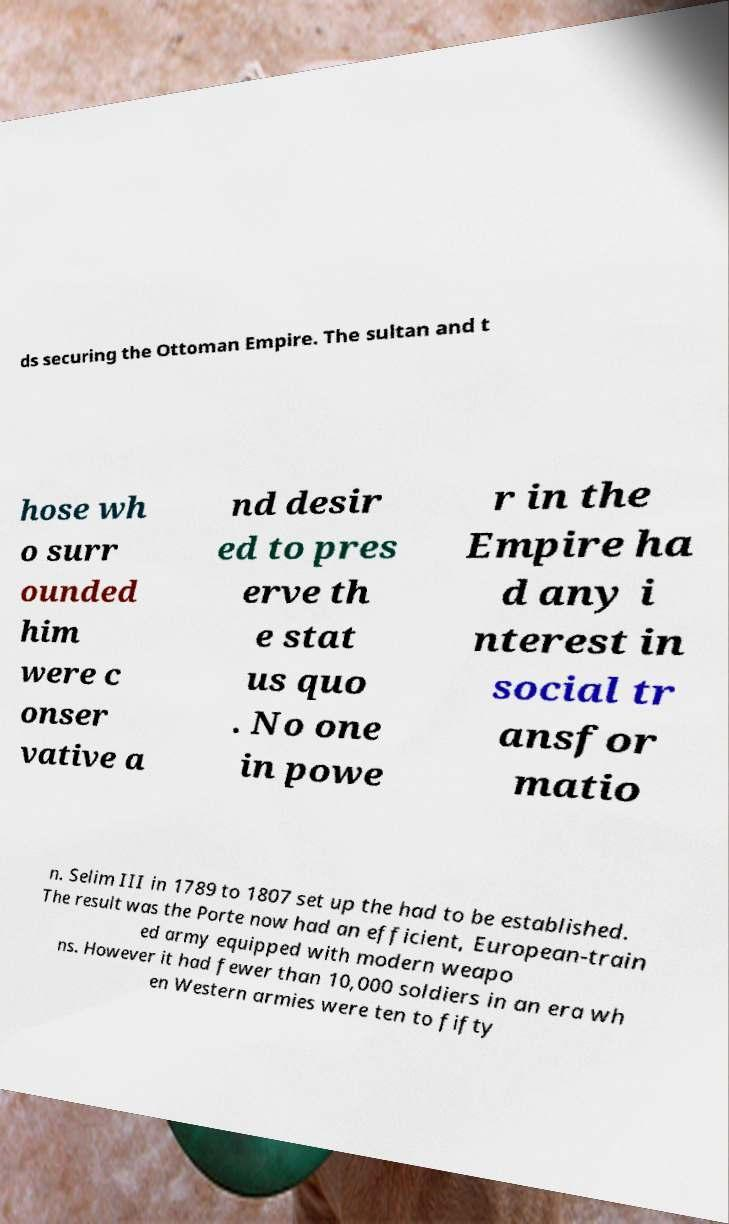Please read and relay the text visible in this image. What does it say? ds securing the Ottoman Empire. The sultan and t hose wh o surr ounded him were c onser vative a nd desir ed to pres erve th e stat us quo . No one in powe r in the Empire ha d any i nterest in social tr ansfor matio n. Selim III in 1789 to 1807 set up the had to be established. The result was the Porte now had an efficient, European-train ed army equipped with modern weapo ns. However it had fewer than 10,000 soldiers in an era wh en Western armies were ten to fifty 